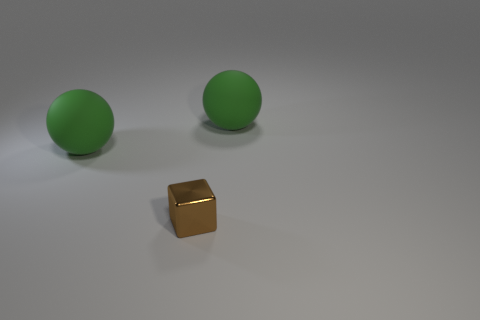Add 3 metallic things. How many objects exist? 6 Subtract all blocks. How many objects are left? 2 Subtract 1 spheres. How many spheres are left? 1 Add 1 large green rubber balls. How many large green rubber balls are left? 3 Add 2 small shiny cubes. How many small shiny cubes exist? 3 Subtract 0 brown spheres. How many objects are left? 3 Subtract all cyan balls. Subtract all yellow cylinders. How many balls are left? 2 Subtract all large green rubber things. Subtract all small metal objects. How many objects are left? 0 